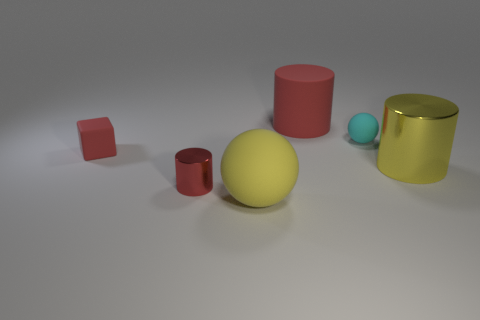Is the color of the tiny matte ball the same as the metal thing that is right of the big yellow rubber ball?
Offer a terse response. No. Are there any other things that have the same material as the large sphere?
Keep it short and to the point. Yes. The tiny red metallic object is what shape?
Give a very brief answer. Cylinder. What size is the object that is in front of the tiny red object that is in front of the tiny rubber block?
Provide a short and direct response. Large. Are there an equal number of shiny objects behind the small red shiny object and big metallic cylinders that are left of the big rubber sphere?
Offer a very short reply. No. There is a thing that is both to the right of the large red matte cylinder and behind the red matte block; what material is it made of?
Give a very brief answer. Rubber. There is a matte block; does it have the same size as the matte sphere behind the large yellow shiny object?
Provide a succinct answer. Yes. How many other objects are the same color as the tiny metallic thing?
Your response must be concise. 2. Are there more yellow balls to the right of the big yellow metal cylinder than small red things?
Your answer should be compact. No. What is the color of the matte ball behind the red rubber thing that is on the left side of the big yellow object left of the small cyan rubber ball?
Offer a very short reply. Cyan. 